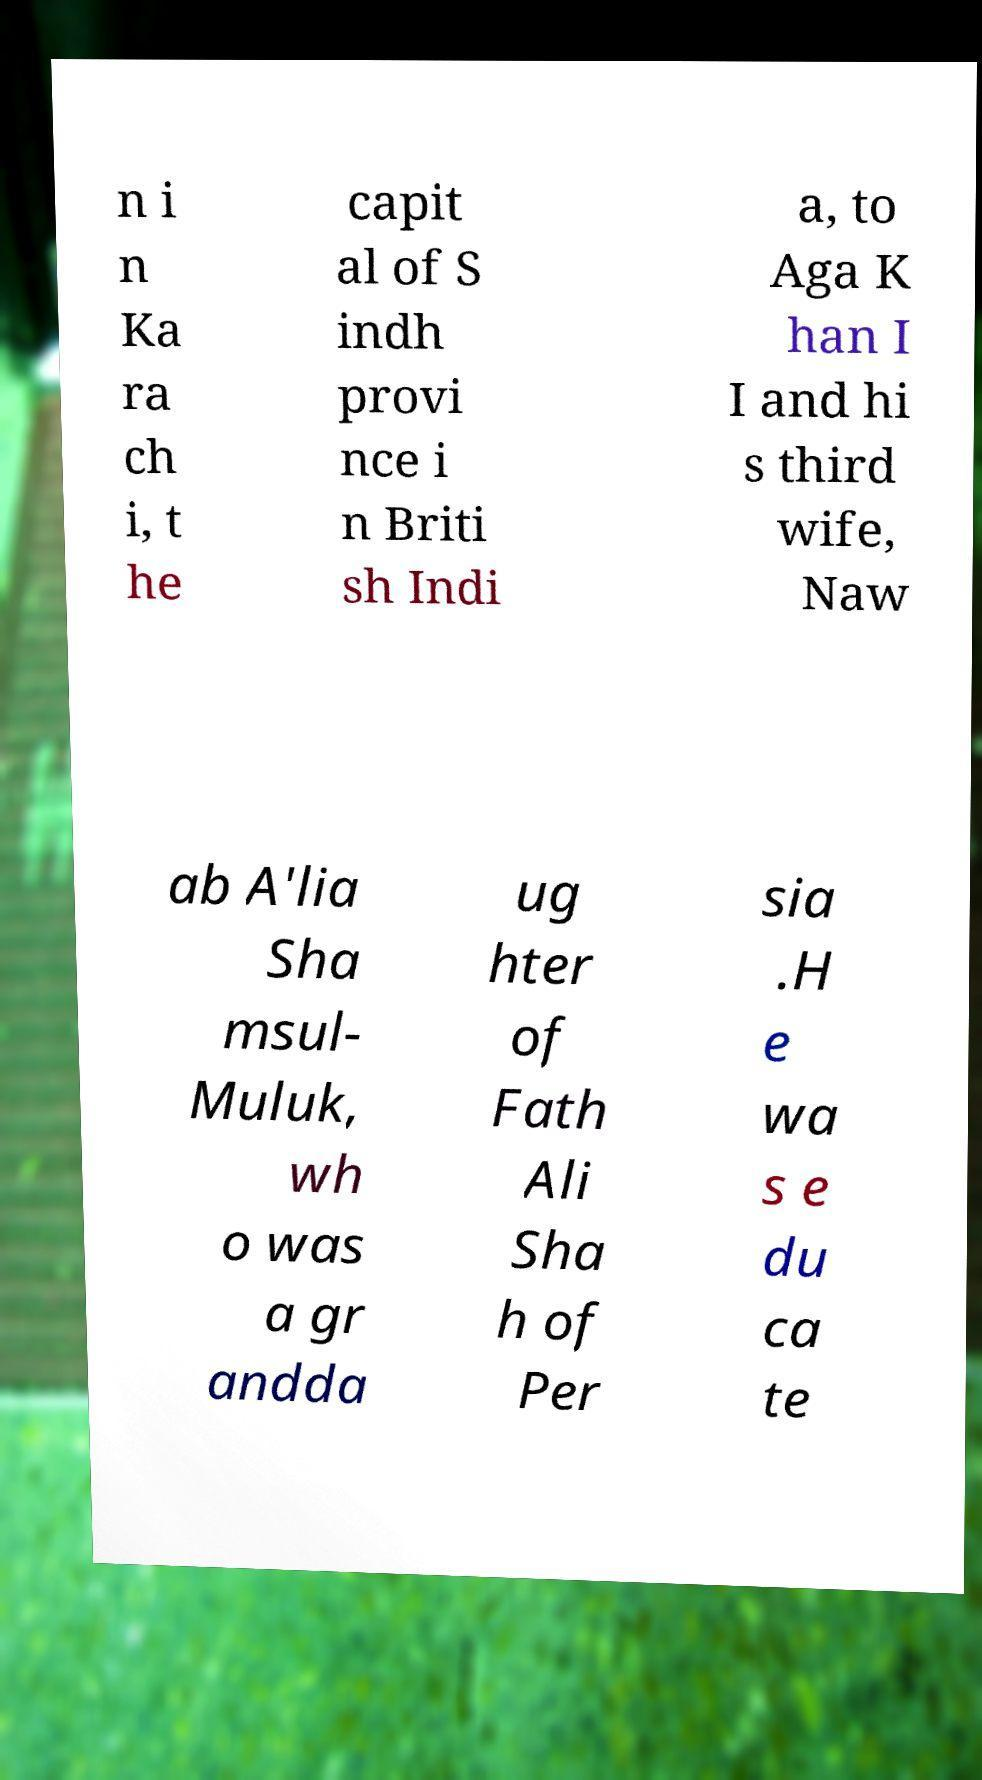What messages or text are displayed in this image? I need them in a readable, typed format. n i n Ka ra ch i, t he capit al of S indh provi nce i n Briti sh Indi a, to Aga K han I I and hi s third wife, Naw ab A'lia Sha msul- Muluk, wh o was a gr andda ug hter of Fath Ali Sha h of Per sia .H e wa s e du ca te 